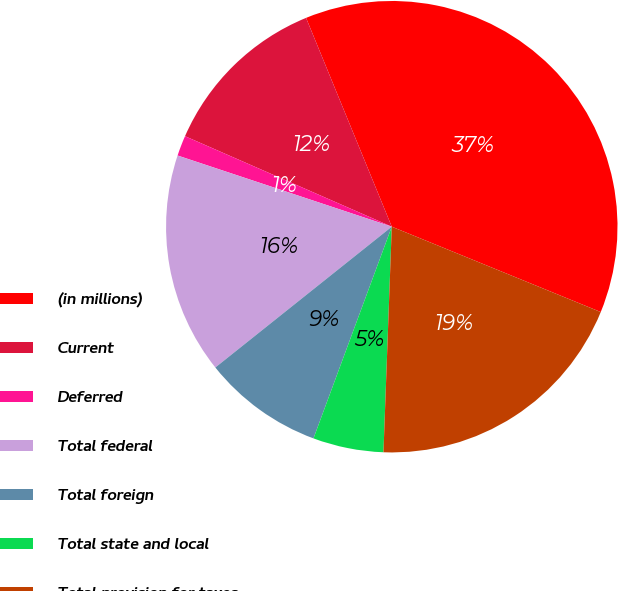<chart> <loc_0><loc_0><loc_500><loc_500><pie_chart><fcel>(in millions)<fcel>Current<fcel>Deferred<fcel>Total federal<fcel>Total foreign<fcel>Total state and local<fcel>Total provision for taxes<nl><fcel>37.36%<fcel>12.23%<fcel>1.46%<fcel>15.82%<fcel>8.64%<fcel>5.05%<fcel>19.41%<nl></chart> 